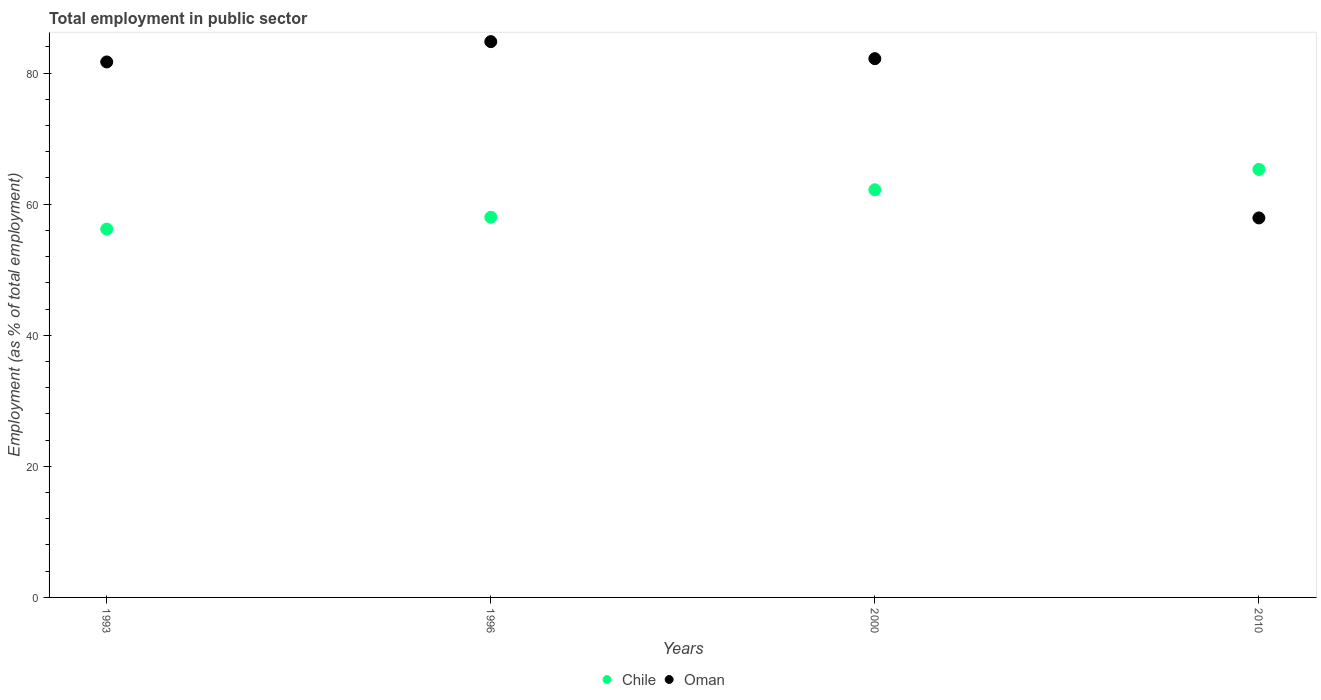How many different coloured dotlines are there?
Ensure brevity in your answer.  2. Is the number of dotlines equal to the number of legend labels?
Your answer should be compact. Yes. What is the employment in public sector in Chile in 1993?
Provide a short and direct response. 56.2. Across all years, what is the maximum employment in public sector in Chile?
Your response must be concise. 65.3. Across all years, what is the minimum employment in public sector in Oman?
Your answer should be compact. 57.9. In which year was the employment in public sector in Oman minimum?
Provide a short and direct response. 2010. What is the total employment in public sector in Chile in the graph?
Offer a very short reply. 241.7. What is the difference between the employment in public sector in Chile in 1996 and that in 2010?
Your response must be concise. -7.3. What is the difference between the employment in public sector in Oman in 1993 and the employment in public sector in Chile in 2000?
Ensure brevity in your answer.  19.5. What is the average employment in public sector in Oman per year?
Ensure brevity in your answer.  76.65. In the year 2000, what is the difference between the employment in public sector in Oman and employment in public sector in Chile?
Offer a terse response. 20. In how many years, is the employment in public sector in Chile greater than 68 %?
Offer a terse response. 0. What is the ratio of the employment in public sector in Oman in 1993 to that in 1996?
Ensure brevity in your answer.  0.96. What is the difference between the highest and the second highest employment in public sector in Oman?
Make the answer very short. 2.6. What is the difference between the highest and the lowest employment in public sector in Oman?
Provide a short and direct response. 26.9. In how many years, is the employment in public sector in Chile greater than the average employment in public sector in Chile taken over all years?
Provide a short and direct response. 2. Does the employment in public sector in Oman monotonically increase over the years?
Keep it short and to the point. No. Is the employment in public sector in Oman strictly less than the employment in public sector in Chile over the years?
Offer a very short reply. No. How many dotlines are there?
Give a very brief answer. 2. How many years are there in the graph?
Provide a succinct answer. 4. Are the values on the major ticks of Y-axis written in scientific E-notation?
Keep it short and to the point. No. Does the graph contain any zero values?
Your response must be concise. No. Where does the legend appear in the graph?
Provide a succinct answer. Bottom center. How are the legend labels stacked?
Provide a short and direct response. Horizontal. What is the title of the graph?
Provide a short and direct response. Total employment in public sector. Does "West Bank and Gaza" appear as one of the legend labels in the graph?
Give a very brief answer. No. What is the label or title of the Y-axis?
Give a very brief answer. Employment (as % of total employment). What is the Employment (as % of total employment) of Chile in 1993?
Offer a very short reply. 56.2. What is the Employment (as % of total employment) in Oman in 1993?
Keep it short and to the point. 81.7. What is the Employment (as % of total employment) in Chile in 1996?
Your response must be concise. 58. What is the Employment (as % of total employment) of Oman in 1996?
Provide a short and direct response. 84.8. What is the Employment (as % of total employment) in Chile in 2000?
Give a very brief answer. 62.2. What is the Employment (as % of total employment) in Oman in 2000?
Make the answer very short. 82.2. What is the Employment (as % of total employment) of Chile in 2010?
Your answer should be very brief. 65.3. What is the Employment (as % of total employment) in Oman in 2010?
Make the answer very short. 57.9. Across all years, what is the maximum Employment (as % of total employment) of Chile?
Make the answer very short. 65.3. Across all years, what is the maximum Employment (as % of total employment) in Oman?
Your answer should be very brief. 84.8. Across all years, what is the minimum Employment (as % of total employment) of Chile?
Make the answer very short. 56.2. Across all years, what is the minimum Employment (as % of total employment) of Oman?
Give a very brief answer. 57.9. What is the total Employment (as % of total employment) in Chile in the graph?
Provide a succinct answer. 241.7. What is the total Employment (as % of total employment) in Oman in the graph?
Provide a short and direct response. 306.6. What is the difference between the Employment (as % of total employment) in Chile in 1993 and that in 1996?
Ensure brevity in your answer.  -1.8. What is the difference between the Employment (as % of total employment) in Oman in 1993 and that in 2010?
Your response must be concise. 23.8. What is the difference between the Employment (as % of total employment) in Chile in 1996 and that in 2000?
Your answer should be compact. -4.2. What is the difference between the Employment (as % of total employment) in Oman in 1996 and that in 2000?
Ensure brevity in your answer.  2.6. What is the difference between the Employment (as % of total employment) of Oman in 1996 and that in 2010?
Ensure brevity in your answer.  26.9. What is the difference between the Employment (as % of total employment) in Oman in 2000 and that in 2010?
Offer a very short reply. 24.3. What is the difference between the Employment (as % of total employment) of Chile in 1993 and the Employment (as % of total employment) of Oman in 1996?
Make the answer very short. -28.6. What is the difference between the Employment (as % of total employment) of Chile in 1996 and the Employment (as % of total employment) of Oman in 2000?
Keep it short and to the point. -24.2. What is the difference between the Employment (as % of total employment) of Chile in 1996 and the Employment (as % of total employment) of Oman in 2010?
Provide a succinct answer. 0.1. What is the difference between the Employment (as % of total employment) in Chile in 2000 and the Employment (as % of total employment) in Oman in 2010?
Your response must be concise. 4.3. What is the average Employment (as % of total employment) of Chile per year?
Give a very brief answer. 60.42. What is the average Employment (as % of total employment) of Oman per year?
Ensure brevity in your answer.  76.65. In the year 1993, what is the difference between the Employment (as % of total employment) of Chile and Employment (as % of total employment) of Oman?
Your response must be concise. -25.5. In the year 1996, what is the difference between the Employment (as % of total employment) of Chile and Employment (as % of total employment) of Oman?
Make the answer very short. -26.8. In the year 2000, what is the difference between the Employment (as % of total employment) of Chile and Employment (as % of total employment) of Oman?
Keep it short and to the point. -20. In the year 2010, what is the difference between the Employment (as % of total employment) of Chile and Employment (as % of total employment) of Oman?
Your answer should be very brief. 7.4. What is the ratio of the Employment (as % of total employment) of Chile in 1993 to that in 1996?
Offer a terse response. 0.97. What is the ratio of the Employment (as % of total employment) in Oman in 1993 to that in 1996?
Ensure brevity in your answer.  0.96. What is the ratio of the Employment (as % of total employment) in Chile in 1993 to that in 2000?
Offer a very short reply. 0.9. What is the ratio of the Employment (as % of total employment) in Chile in 1993 to that in 2010?
Offer a terse response. 0.86. What is the ratio of the Employment (as % of total employment) of Oman in 1993 to that in 2010?
Keep it short and to the point. 1.41. What is the ratio of the Employment (as % of total employment) of Chile in 1996 to that in 2000?
Offer a very short reply. 0.93. What is the ratio of the Employment (as % of total employment) of Oman in 1996 to that in 2000?
Provide a short and direct response. 1.03. What is the ratio of the Employment (as % of total employment) of Chile in 1996 to that in 2010?
Ensure brevity in your answer.  0.89. What is the ratio of the Employment (as % of total employment) in Oman in 1996 to that in 2010?
Your response must be concise. 1.46. What is the ratio of the Employment (as % of total employment) of Chile in 2000 to that in 2010?
Provide a short and direct response. 0.95. What is the ratio of the Employment (as % of total employment) of Oman in 2000 to that in 2010?
Your response must be concise. 1.42. What is the difference between the highest and the second highest Employment (as % of total employment) in Oman?
Provide a short and direct response. 2.6. What is the difference between the highest and the lowest Employment (as % of total employment) in Oman?
Your response must be concise. 26.9. 